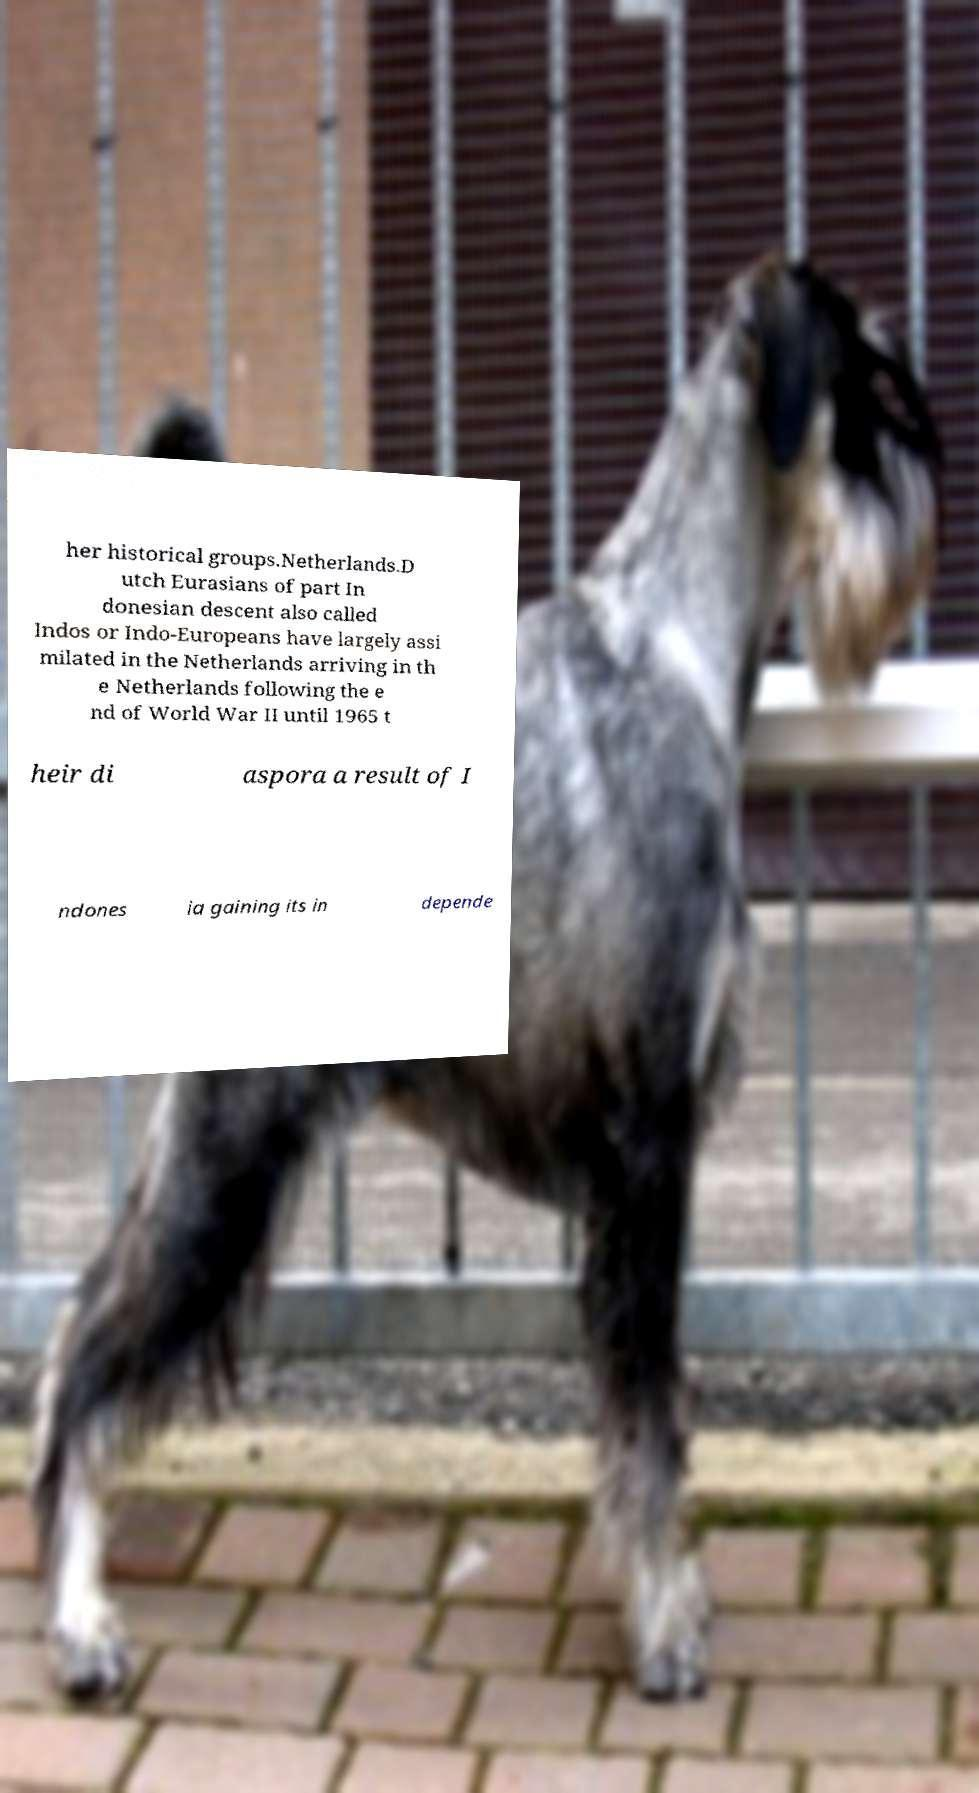For documentation purposes, I need the text within this image transcribed. Could you provide that? her historical groups.Netherlands.D utch Eurasians of part In donesian descent also called Indos or Indo-Europeans have largely assi milated in the Netherlands arriving in th e Netherlands following the e nd of World War II until 1965 t heir di aspora a result of I ndones ia gaining its in depende 